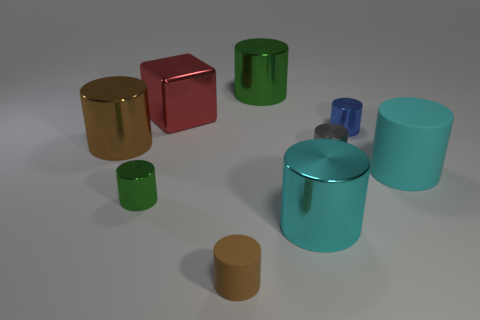Is there a large red object of the same shape as the brown rubber object?
Make the answer very short. No. How many things are either green metal things that are in front of the large green shiny thing or small matte cylinders?
Keep it short and to the point. 2. There is a tiny metal cylinder that is to the left of the large green metallic object; is it the same color as the large metallic object that is behind the large block?
Keep it short and to the point. Yes. The blue cylinder has what size?
Your answer should be very brief. Small. What number of big things are blue metal cylinders or brown cylinders?
Offer a very short reply. 1. What is the color of the matte thing that is the same size as the gray cylinder?
Make the answer very short. Brown. What number of other objects are the same shape as the blue object?
Keep it short and to the point. 7. Is there a tiny blue object made of the same material as the gray object?
Give a very brief answer. Yes. Does the gray cylinder in front of the large green metal cylinder have the same material as the cyan object that is on the right side of the blue thing?
Provide a short and direct response. No. What number of gray metallic cylinders are there?
Ensure brevity in your answer.  1. 